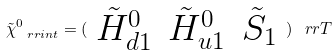Convert formula to latex. <formula><loc_0><loc_0><loc_500><loc_500>\tilde { \chi } _ { \ r r { i n t } } ^ { 0 } = ( \begin{array} { c c c } \tilde { H } _ { d 1 } ^ { 0 } & \tilde { H } _ { u 1 } ^ { 0 } & \tilde { S } _ { 1 } \end{array} ) ^ { \ } r r { T }</formula> 